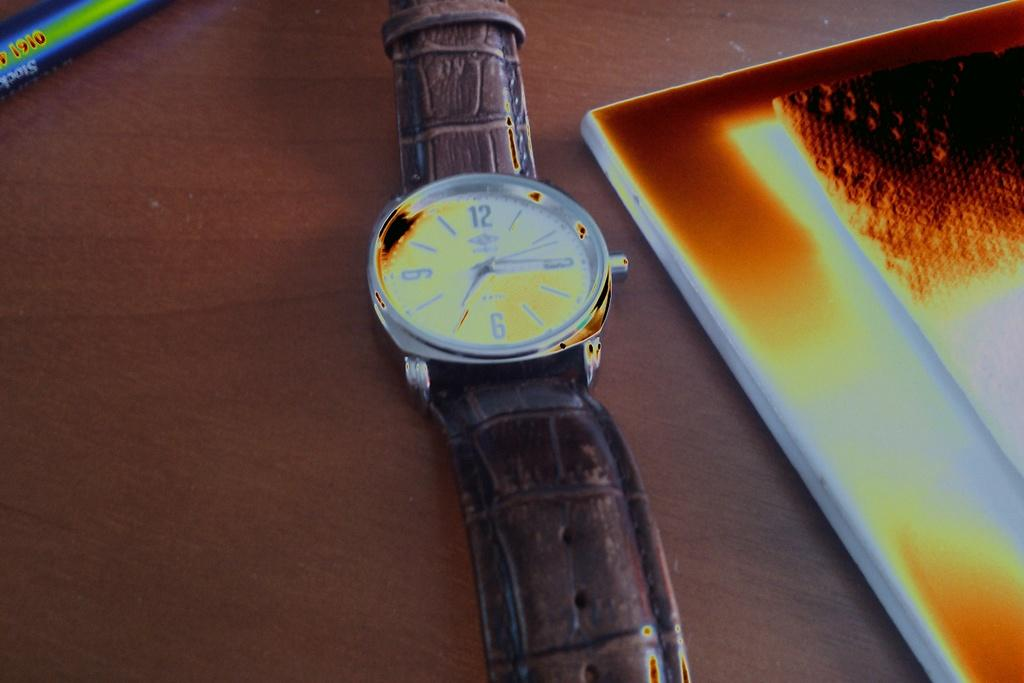<image>
Provide a brief description of the given image. A blue and green object in the corner has 1910 on it 